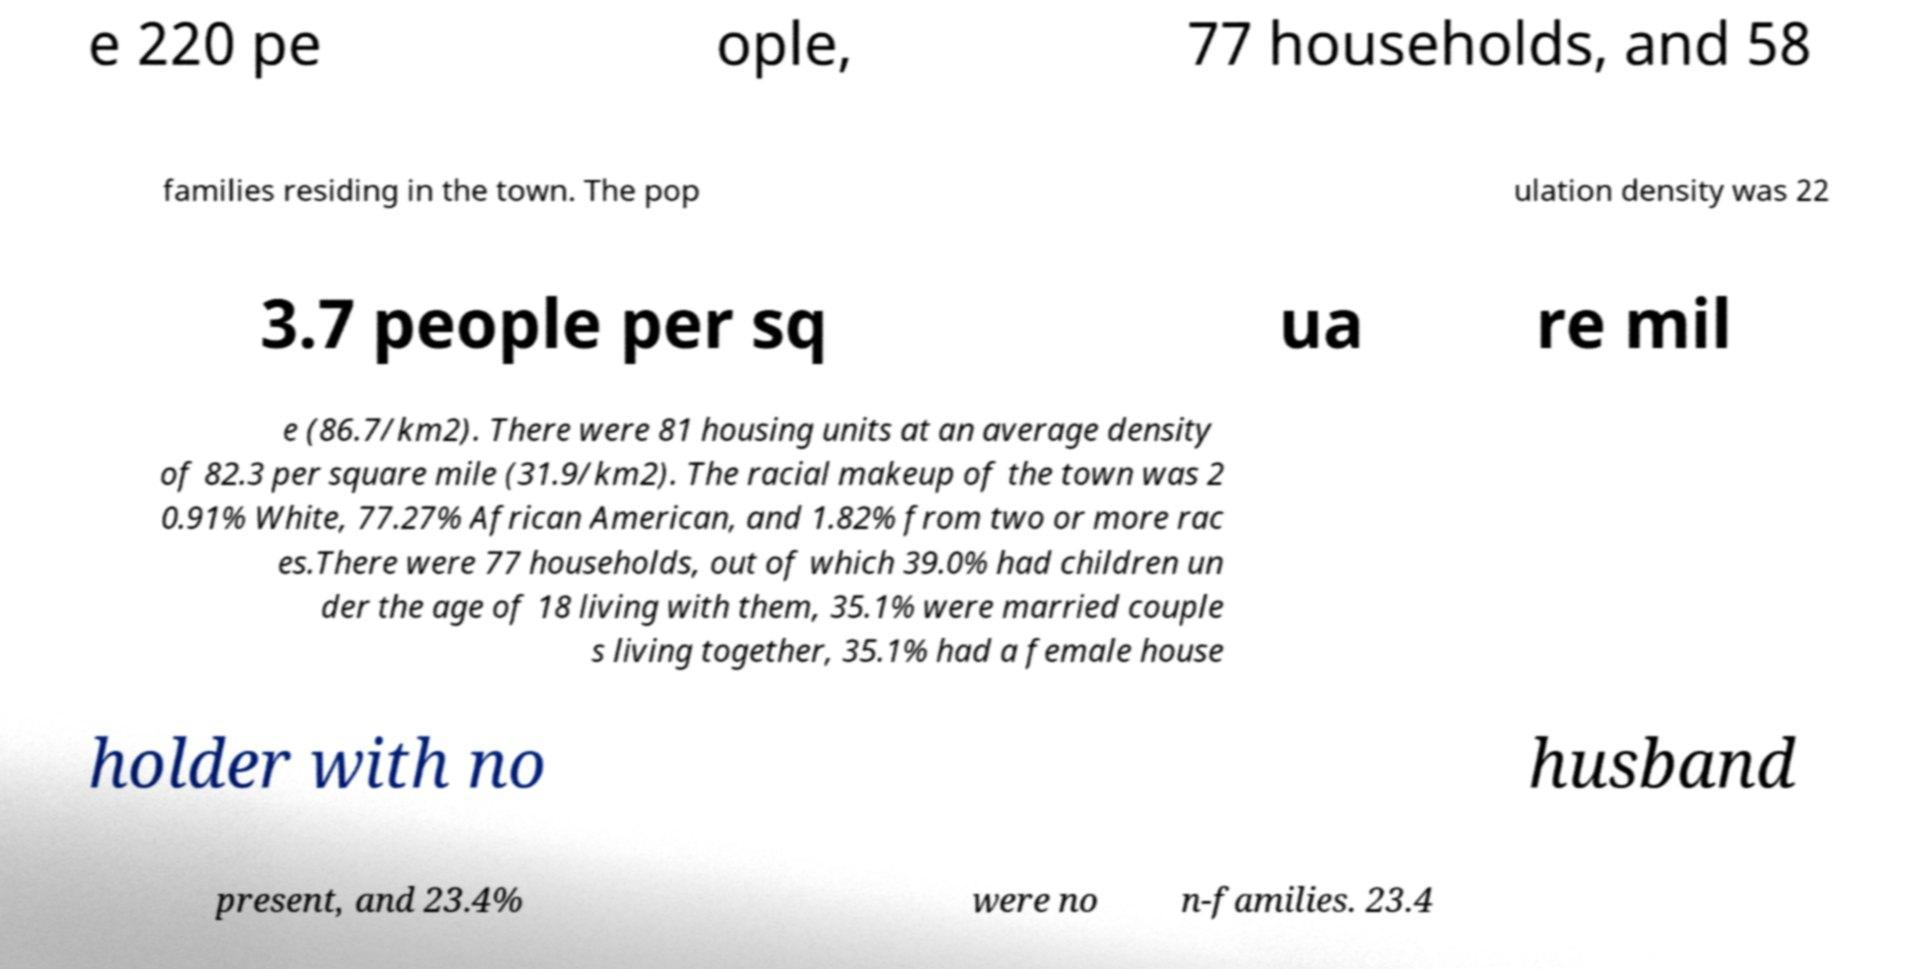Could you extract and type out the text from this image? e 220 pe ople, 77 households, and 58 families residing in the town. The pop ulation density was 22 3.7 people per sq ua re mil e (86.7/km2). There were 81 housing units at an average density of 82.3 per square mile (31.9/km2). The racial makeup of the town was 2 0.91% White, 77.27% African American, and 1.82% from two or more rac es.There were 77 households, out of which 39.0% had children un der the age of 18 living with them, 35.1% were married couple s living together, 35.1% had a female house holder with no husband present, and 23.4% were no n-families. 23.4 